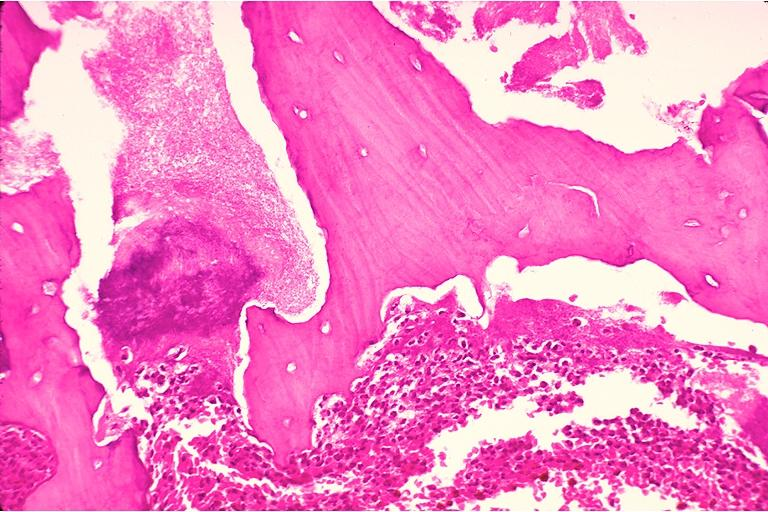does this image show chronic osteomyelitis?
Answer the question using a single word or phrase. Yes 